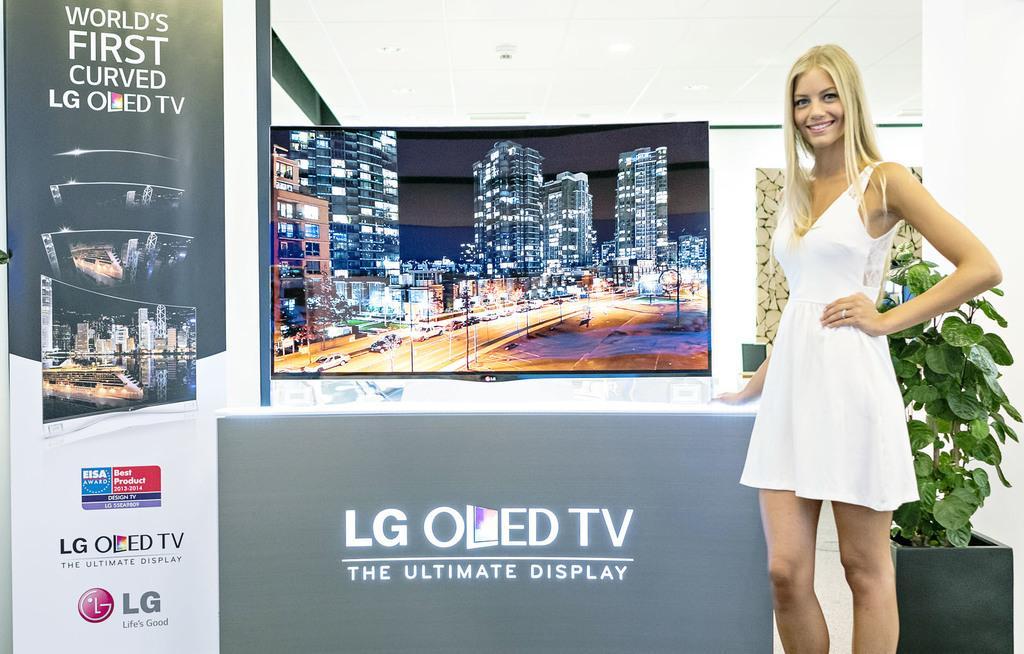Can you describe this image briefly? On the right side, we see a plant pot. Beside that, we see a woman in the white dress is stunning. She is smiling and she is posing for the photo. Behind her, we see a banner or a board with some text written on it. We even see the poles, street lights, buildings and the cars which are moving on the road. 